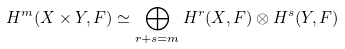<formula> <loc_0><loc_0><loc_500><loc_500>H ^ { m } ( X \times Y , F ) \simeq \bigoplus _ { r + s = m } H ^ { r } ( X , F ) \otimes H ^ { s } ( Y , F )</formula> 